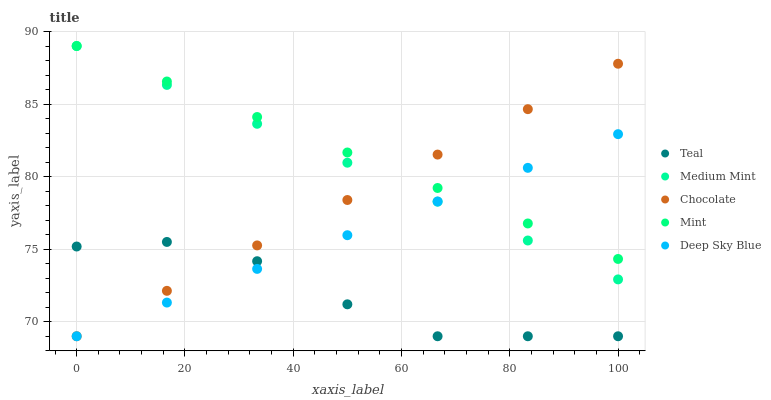Does Teal have the minimum area under the curve?
Answer yes or no. Yes. Does Mint have the maximum area under the curve?
Answer yes or no. Yes. Does Deep Sky Blue have the minimum area under the curve?
Answer yes or no. No. Does Deep Sky Blue have the maximum area under the curve?
Answer yes or no. No. Is Mint the smoothest?
Answer yes or no. Yes. Is Teal the roughest?
Answer yes or no. Yes. Is Deep Sky Blue the smoothest?
Answer yes or no. No. Is Deep Sky Blue the roughest?
Answer yes or no. No. Does Deep Sky Blue have the lowest value?
Answer yes or no. Yes. Does Mint have the lowest value?
Answer yes or no. No. Does Mint have the highest value?
Answer yes or no. Yes. Does Deep Sky Blue have the highest value?
Answer yes or no. No. Is Teal less than Medium Mint?
Answer yes or no. Yes. Is Medium Mint greater than Teal?
Answer yes or no. Yes. Does Chocolate intersect Medium Mint?
Answer yes or no. Yes. Is Chocolate less than Medium Mint?
Answer yes or no. No. Is Chocolate greater than Medium Mint?
Answer yes or no. No. Does Teal intersect Medium Mint?
Answer yes or no. No. 